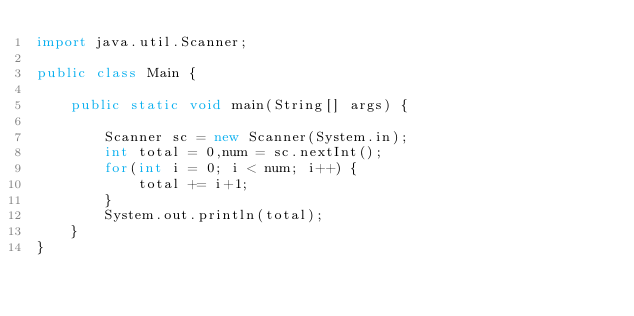<code> <loc_0><loc_0><loc_500><loc_500><_Java_>import java.util.Scanner;

public class Main {

	public static void main(String[] args) {

		Scanner sc = new Scanner(System.in);
		int total = 0,num = sc.nextInt();
		for(int i = 0; i < num; i++) {
			total += i+1;
		}
		System.out.println(total);
	}
}
</code> 